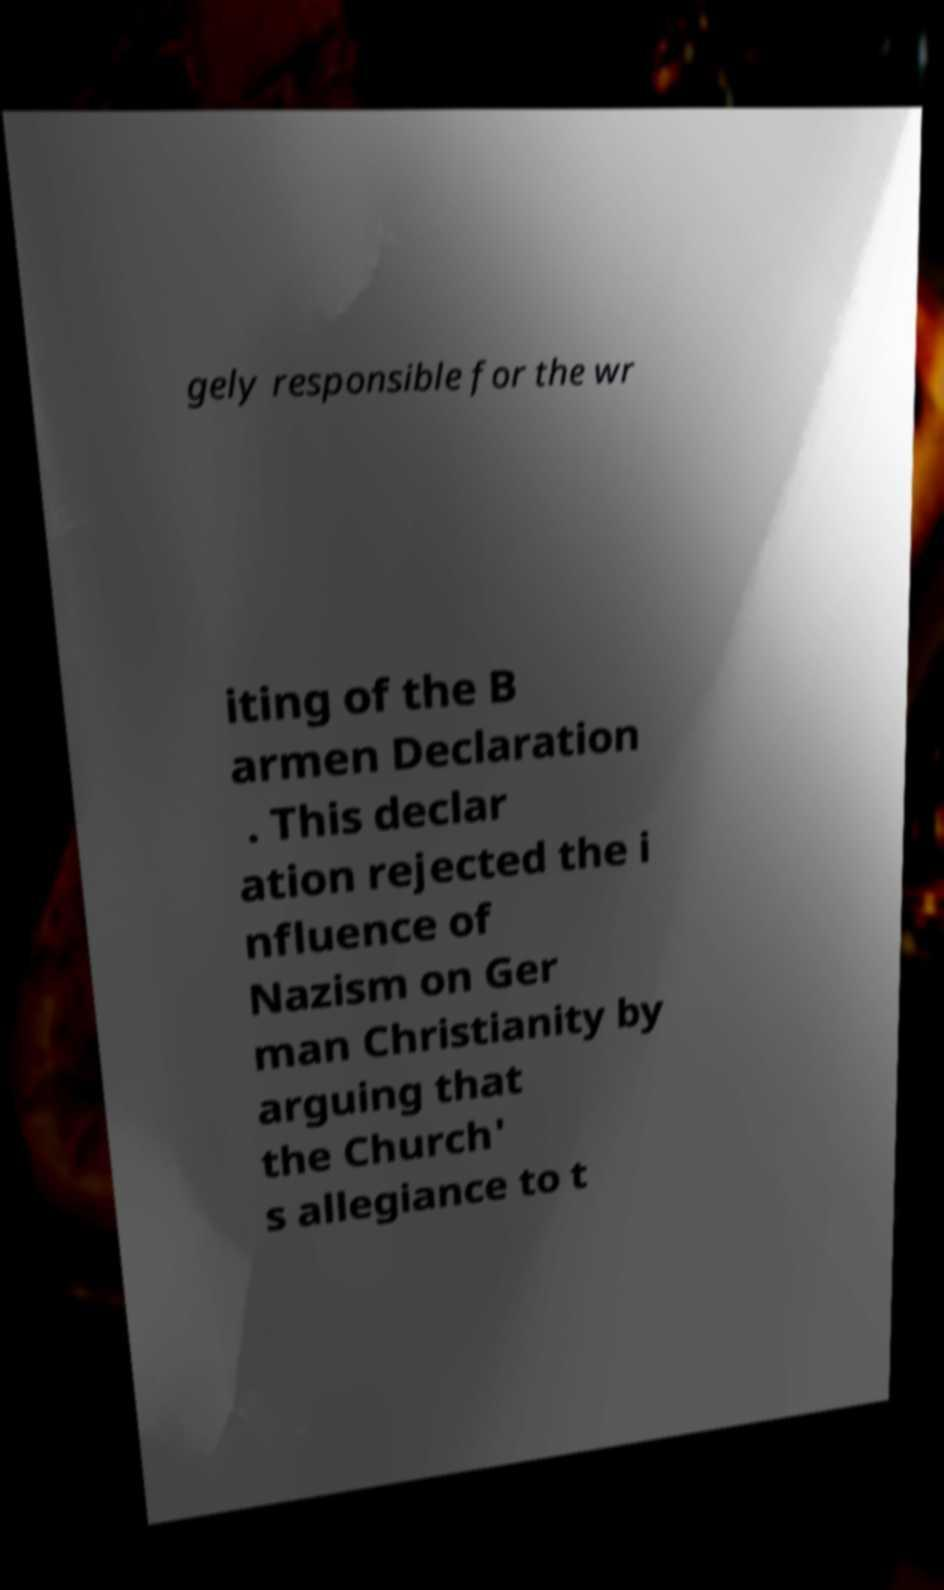Could you extract and type out the text from this image? gely responsible for the wr iting of the B armen Declaration . This declar ation rejected the i nfluence of Nazism on Ger man Christianity by arguing that the Church' s allegiance to t 